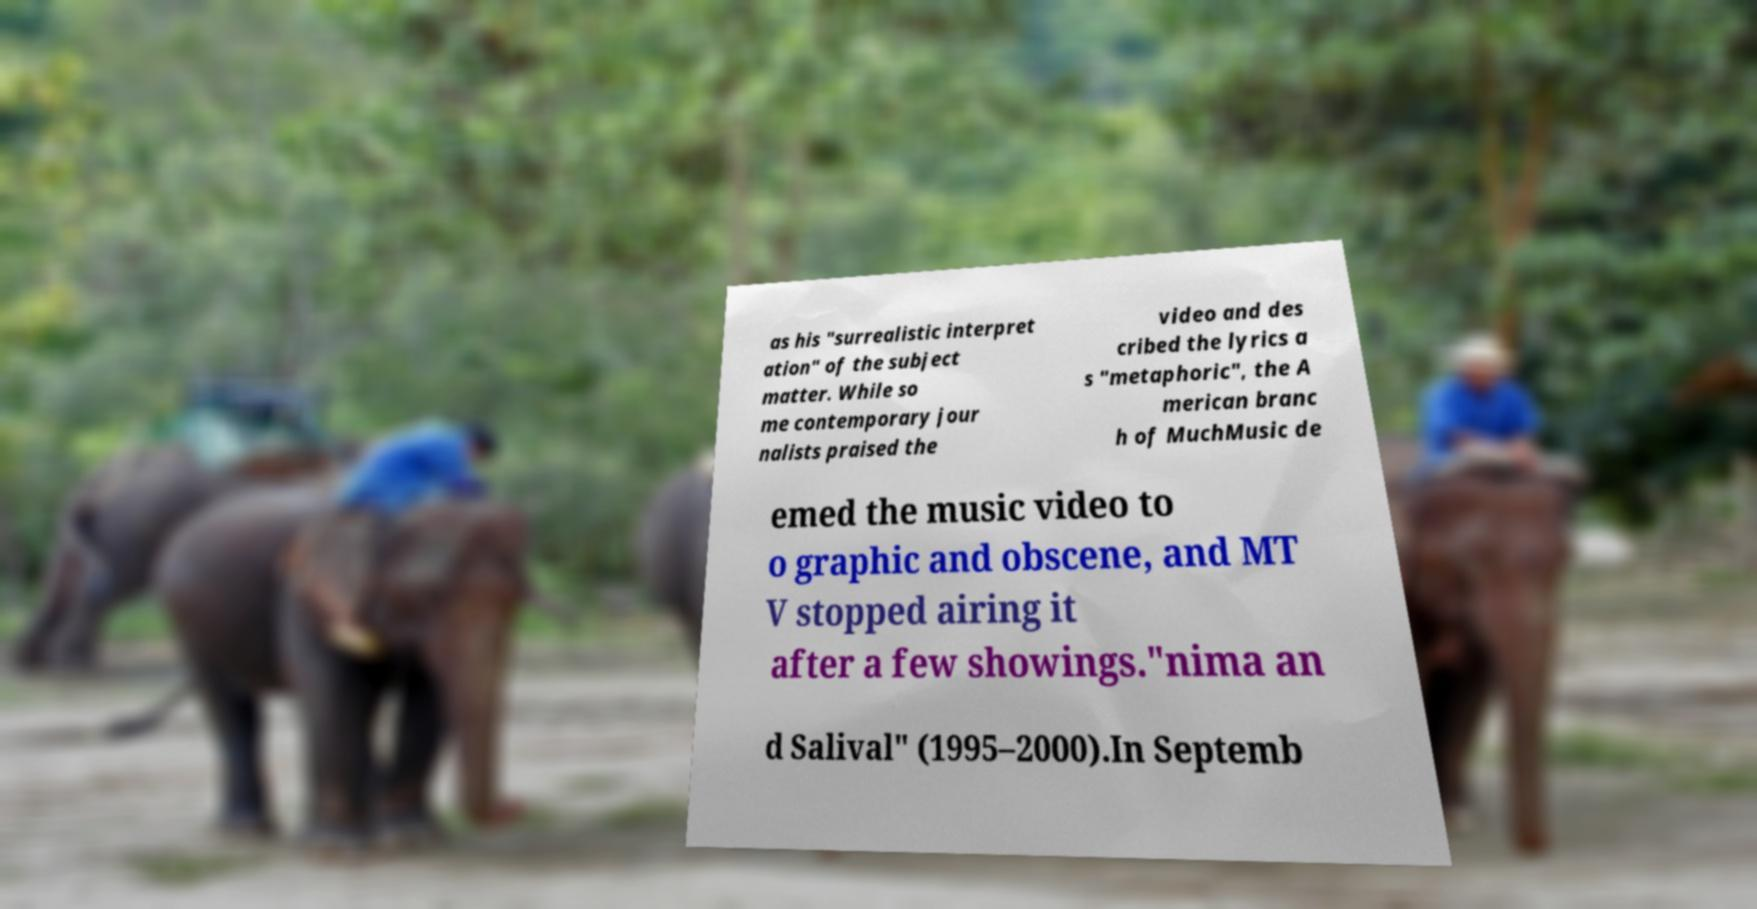Could you assist in decoding the text presented in this image and type it out clearly? as his "surrealistic interpret ation" of the subject matter. While so me contemporary jour nalists praised the video and des cribed the lyrics a s "metaphoric", the A merican branc h of MuchMusic de emed the music video to o graphic and obscene, and MT V stopped airing it after a few showings."nima an d Salival" (1995–2000).In Septemb 